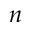Convert formula to latex. <formula><loc_0><loc_0><loc_500><loc_500>n</formula> 